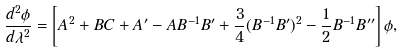<formula> <loc_0><loc_0><loc_500><loc_500>\frac { d ^ { 2 } \phi } { d \lambda ^ { 2 } } = \left [ A ^ { 2 } + B C + A ^ { \prime } - A B ^ { - 1 } B ^ { \prime } + \frac { 3 } { 4 } ( B ^ { - 1 } B ^ { \prime } ) ^ { 2 } - \frac { 1 } { 2 } B ^ { - 1 } B ^ { \prime \prime } \right ] \phi ,</formula> 